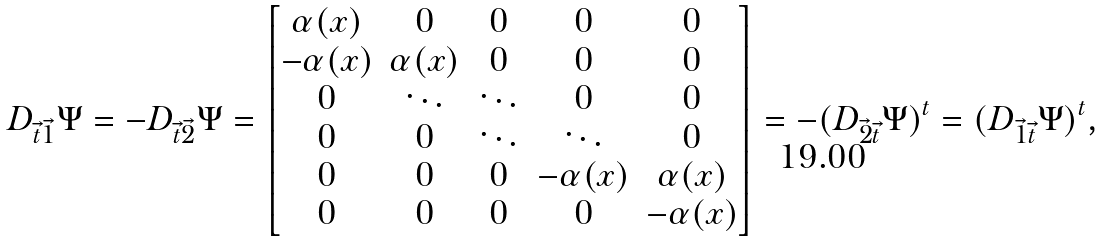<formula> <loc_0><loc_0><loc_500><loc_500>D _ { \vec { t } \vec { 1 } } \Psi = - D _ { \vec { t } \vec { 2 } } \Psi = \begin{bmatrix} \alpha ( x ) & 0 & 0 & 0 & 0 \\ - \alpha ( x ) & \alpha ( x ) & 0 & 0 & 0 \\ 0 & \ddots & \ddots & 0 & 0 \\ 0 & 0 & \ddots & \ddots & 0 \\ 0 & 0 & 0 & - \alpha ( x ) & \alpha ( x ) \\ 0 & 0 & 0 & 0 & - \alpha ( x ) \end{bmatrix} = - ( D _ { \vec { 2 } \vec { t } } \Psi ) ^ { t } = ( D _ { \vec { 1 } \vec { t } } \Psi ) ^ { t } ,</formula> 